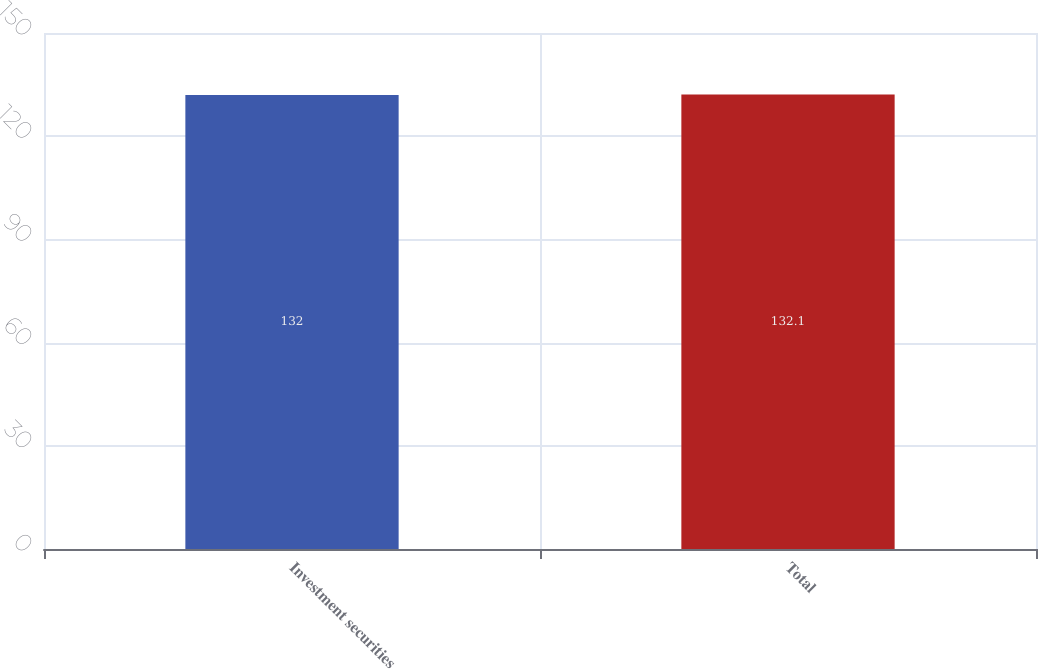Convert chart to OTSL. <chart><loc_0><loc_0><loc_500><loc_500><bar_chart><fcel>Investment securities<fcel>Total<nl><fcel>132<fcel>132.1<nl></chart> 